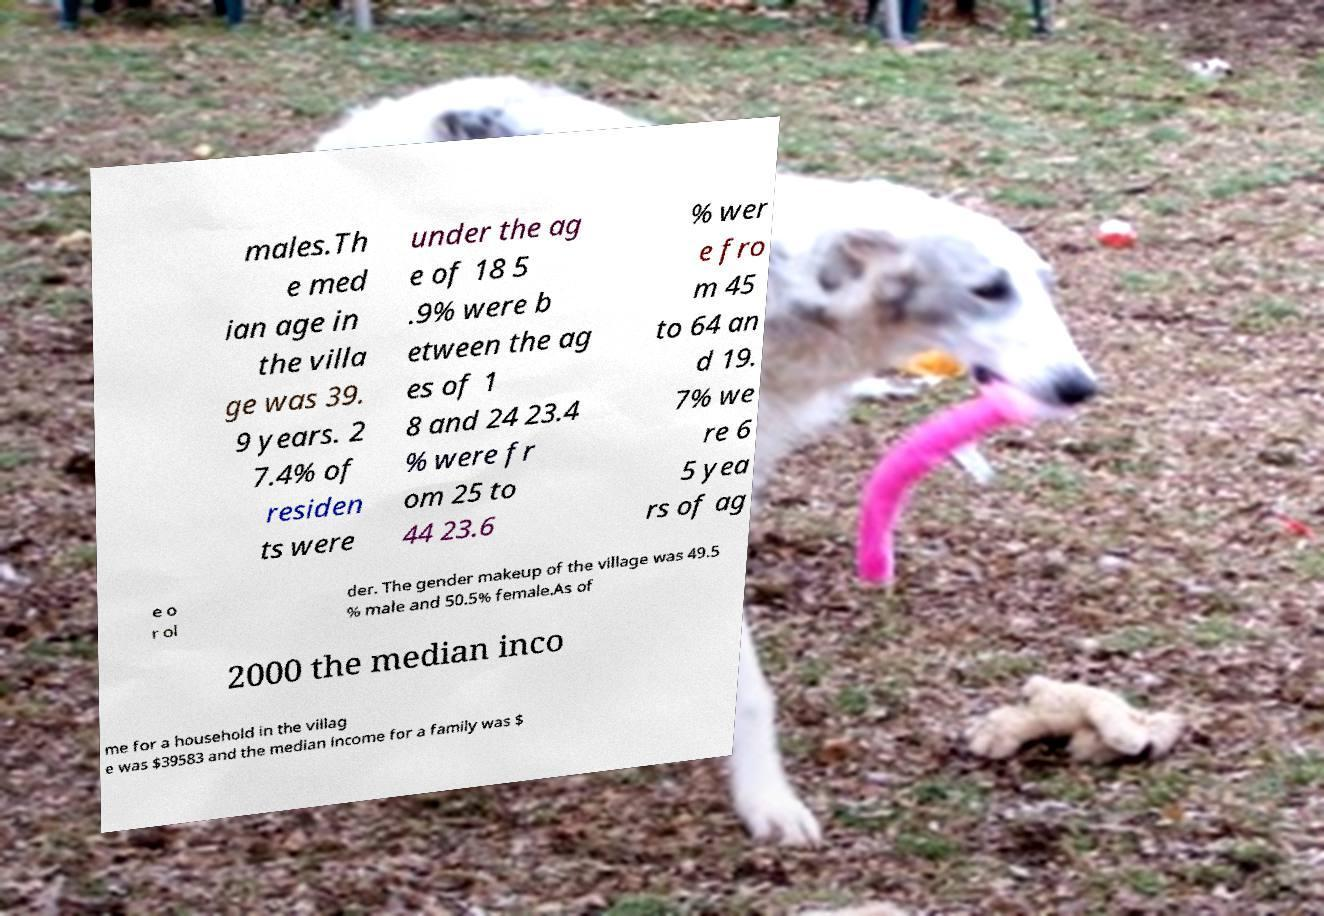For documentation purposes, I need the text within this image transcribed. Could you provide that? males.Th e med ian age in the villa ge was 39. 9 years. 2 7.4% of residen ts were under the ag e of 18 5 .9% were b etween the ag es of 1 8 and 24 23.4 % were fr om 25 to 44 23.6 % wer e fro m 45 to 64 an d 19. 7% we re 6 5 yea rs of ag e o r ol der. The gender makeup of the village was 49.5 % male and 50.5% female.As of 2000 the median inco me for a household in the villag e was $39583 and the median income for a family was $ 